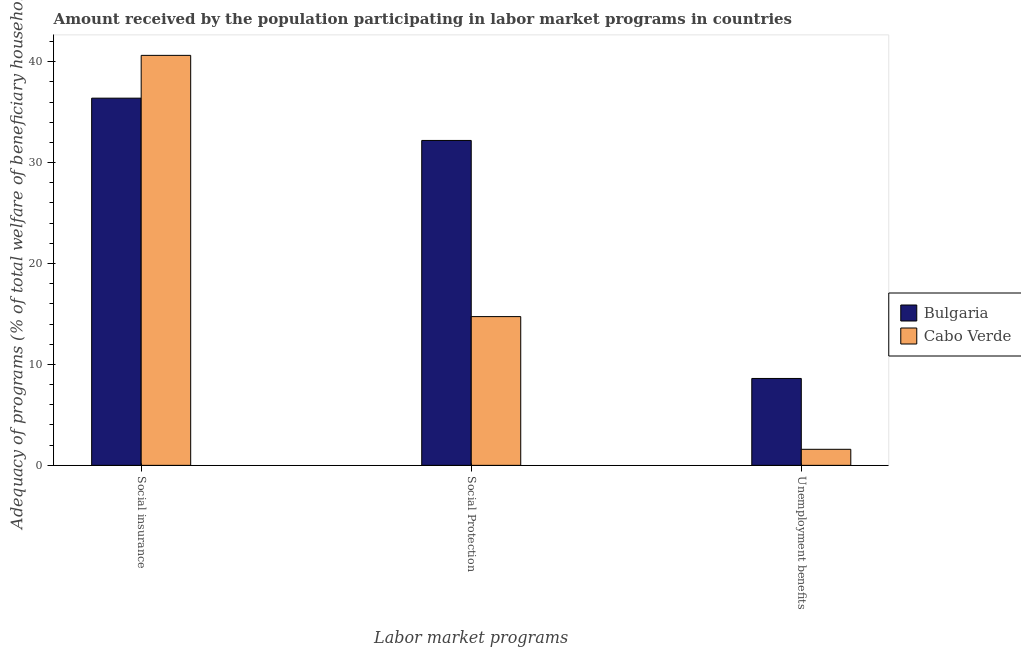How many different coloured bars are there?
Keep it short and to the point. 2. How many bars are there on the 1st tick from the left?
Ensure brevity in your answer.  2. How many bars are there on the 2nd tick from the right?
Your answer should be very brief. 2. What is the label of the 1st group of bars from the left?
Ensure brevity in your answer.  Social insurance. What is the amount received by the population participating in social insurance programs in Bulgaria?
Offer a very short reply. 36.38. Across all countries, what is the maximum amount received by the population participating in unemployment benefits programs?
Make the answer very short. 8.61. Across all countries, what is the minimum amount received by the population participating in social protection programs?
Ensure brevity in your answer.  14.74. In which country was the amount received by the population participating in social insurance programs minimum?
Your answer should be compact. Bulgaria. What is the total amount received by the population participating in unemployment benefits programs in the graph?
Provide a short and direct response. 10.2. What is the difference between the amount received by the population participating in social protection programs in Bulgaria and that in Cabo Verde?
Offer a very short reply. 17.45. What is the difference between the amount received by the population participating in social protection programs in Cabo Verde and the amount received by the population participating in unemployment benefits programs in Bulgaria?
Ensure brevity in your answer.  6.13. What is the average amount received by the population participating in social protection programs per country?
Your response must be concise. 23.46. What is the difference between the amount received by the population participating in social insurance programs and amount received by the population participating in social protection programs in Bulgaria?
Your answer should be compact. 4.19. In how many countries, is the amount received by the population participating in social protection programs greater than 36 %?
Ensure brevity in your answer.  0. What is the ratio of the amount received by the population participating in social protection programs in Bulgaria to that in Cabo Verde?
Keep it short and to the point. 2.18. What is the difference between the highest and the second highest amount received by the population participating in unemployment benefits programs?
Keep it short and to the point. 7.02. What is the difference between the highest and the lowest amount received by the population participating in social insurance programs?
Provide a succinct answer. 4.24. Is the sum of the amount received by the population participating in unemployment benefits programs in Cabo Verde and Bulgaria greater than the maximum amount received by the population participating in social insurance programs across all countries?
Make the answer very short. No. What does the 2nd bar from the right in Unemployment benefits represents?
Your response must be concise. Bulgaria. Is it the case that in every country, the sum of the amount received by the population participating in social insurance programs and amount received by the population participating in social protection programs is greater than the amount received by the population participating in unemployment benefits programs?
Ensure brevity in your answer.  Yes. How many bars are there?
Ensure brevity in your answer.  6. Where does the legend appear in the graph?
Provide a short and direct response. Center right. What is the title of the graph?
Your answer should be compact. Amount received by the population participating in labor market programs in countries. What is the label or title of the X-axis?
Make the answer very short. Labor market programs. What is the label or title of the Y-axis?
Offer a very short reply. Adequacy of programs (% of total welfare of beneficiary households). What is the Adequacy of programs (% of total welfare of beneficiary households) in Bulgaria in Social insurance?
Give a very brief answer. 36.38. What is the Adequacy of programs (% of total welfare of beneficiary households) of Cabo Verde in Social insurance?
Your answer should be compact. 40.62. What is the Adequacy of programs (% of total welfare of beneficiary households) of Bulgaria in Social Protection?
Make the answer very short. 32.19. What is the Adequacy of programs (% of total welfare of beneficiary households) in Cabo Verde in Social Protection?
Your answer should be very brief. 14.74. What is the Adequacy of programs (% of total welfare of beneficiary households) in Bulgaria in Unemployment benefits?
Provide a succinct answer. 8.61. What is the Adequacy of programs (% of total welfare of beneficiary households) in Cabo Verde in Unemployment benefits?
Keep it short and to the point. 1.59. Across all Labor market programs, what is the maximum Adequacy of programs (% of total welfare of beneficiary households) of Bulgaria?
Your answer should be compact. 36.38. Across all Labor market programs, what is the maximum Adequacy of programs (% of total welfare of beneficiary households) in Cabo Verde?
Your answer should be compact. 40.62. Across all Labor market programs, what is the minimum Adequacy of programs (% of total welfare of beneficiary households) of Bulgaria?
Your response must be concise. 8.61. Across all Labor market programs, what is the minimum Adequacy of programs (% of total welfare of beneficiary households) in Cabo Verde?
Ensure brevity in your answer.  1.59. What is the total Adequacy of programs (% of total welfare of beneficiary households) of Bulgaria in the graph?
Your response must be concise. 77.18. What is the total Adequacy of programs (% of total welfare of beneficiary households) in Cabo Verde in the graph?
Give a very brief answer. 56.95. What is the difference between the Adequacy of programs (% of total welfare of beneficiary households) of Bulgaria in Social insurance and that in Social Protection?
Give a very brief answer. 4.19. What is the difference between the Adequacy of programs (% of total welfare of beneficiary households) in Cabo Verde in Social insurance and that in Social Protection?
Make the answer very short. 25.88. What is the difference between the Adequacy of programs (% of total welfare of beneficiary households) of Bulgaria in Social insurance and that in Unemployment benefits?
Offer a very short reply. 27.77. What is the difference between the Adequacy of programs (% of total welfare of beneficiary households) in Cabo Verde in Social insurance and that in Unemployment benefits?
Your answer should be compact. 39.03. What is the difference between the Adequacy of programs (% of total welfare of beneficiary households) in Bulgaria in Social Protection and that in Unemployment benefits?
Ensure brevity in your answer.  23.58. What is the difference between the Adequacy of programs (% of total welfare of beneficiary households) in Cabo Verde in Social Protection and that in Unemployment benefits?
Your response must be concise. 13.15. What is the difference between the Adequacy of programs (% of total welfare of beneficiary households) of Bulgaria in Social insurance and the Adequacy of programs (% of total welfare of beneficiary households) of Cabo Verde in Social Protection?
Your answer should be very brief. 21.64. What is the difference between the Adequacy of programs (% of total welfare of beneficiary households) of Bulgaria in Social insurance and the Adequacy of programs (% of total welfare of beneficiary households) of Cabo Verde in Unemployment benefits?
Provide a succinct answer. 34.79. What is the difference between the Adequacy of programs (% of total welfare of beneficiary households) in Bulgaria in Social Protection and the Adequacy of programs (% of total welfare of beneficiary households) in Cabo Verde in Unemployment benefits?
Your answer should be very brief. 30.6. What is the average Adequacy of programs (% of total welfare of beneficiary households) of Bulgaria per Labor market programs?
Your answer should be compact. 25.73. What is the average Adequacy of programs (% of total welfare of beneficiary households) in Cabo Verde per Labor market programs?
Your answer should be compact. 18.98. What is the difference between the Adequacy of programs (% of total welfare of beneficiary households) of Bulgaria and Adequacy of programs (% of total welfare of beneficiary households) of Cabo Verde in Social insurance?
Provide a short and direct response. -4.24. What is the difference between the Adequacy of programs (% of total welfare of beneficiary households) in Bulgaria and Adequacy of programs (% of total welfare of beneficiary households) in Cabo Verde in Social Protection?
Offer a terse response. 17.45. What is the difference between the Adequacy of programs (% of total welfare of beneficiary households) of Bulgaria and Adequacy of programs (% of total welfare of beneficiary households) of Cabo Verde in Unemployment benefits?
Provide a succinct answer. 7.02. What is the ratio of the Adequacy of programs (% of total welfare of beneficiary households) of Bulgaria in Social insurance to that in Social Protection?
Your answer should be very brief. 1.13. What is the ratio of the Adequacy of programs (% of total welfare of beneficiary households) in Cabo Verde in Social insurance to that in Social Protection?
Provide a short and direct response. 2.76. What is the ratio of the Adequacy of programs (% of total welfare of beneficiary households) in Bulgaria in Social insurance to that in Unemployment benefits?
Offer a very short reply. 4.23. What is the ratio of the Adequacy of programs (% of total welfare of beneficiary households) in Cabo Verde in Social insurance to that in Unemployment benefits?
Your answer should be compact. 25.56. What is the ratio of the Adequacy of programs (% of total welfare of beneficiary households) of Bulgaria in Social Protection to that in Unemployment benefits?
Offer a very short reply. 3.74. What is the ratio of the Adequacy of programs (% of total welfare of beneficiary households) in Cabo Verde in Social Protection to that in Unemployment benefits?
Provide a short and direct response. 9.27. What is the difference between the highest and the second highest Adequacy of programs (% of total welfare of beneficiary households) of Bulgaria?
Provide a short and direct response. 4.19. What is the difference between the highest and the second highest Adequacy of programs (% of total welfare of beneficiary households) of Cabo Verde?
Provide a short and direct response. 25.88. What is the difference between the highest and the lowest Adequacy of programs (% of total welfare of beneficiary households) of Bulgaria?
Offer a terse response. 27.77. What is the difference between the highest and the lowest Adequacy of programs (% of total welfare of beneficiary households) of Cabo Verde?
Keep it short and to the point. 39.03. 